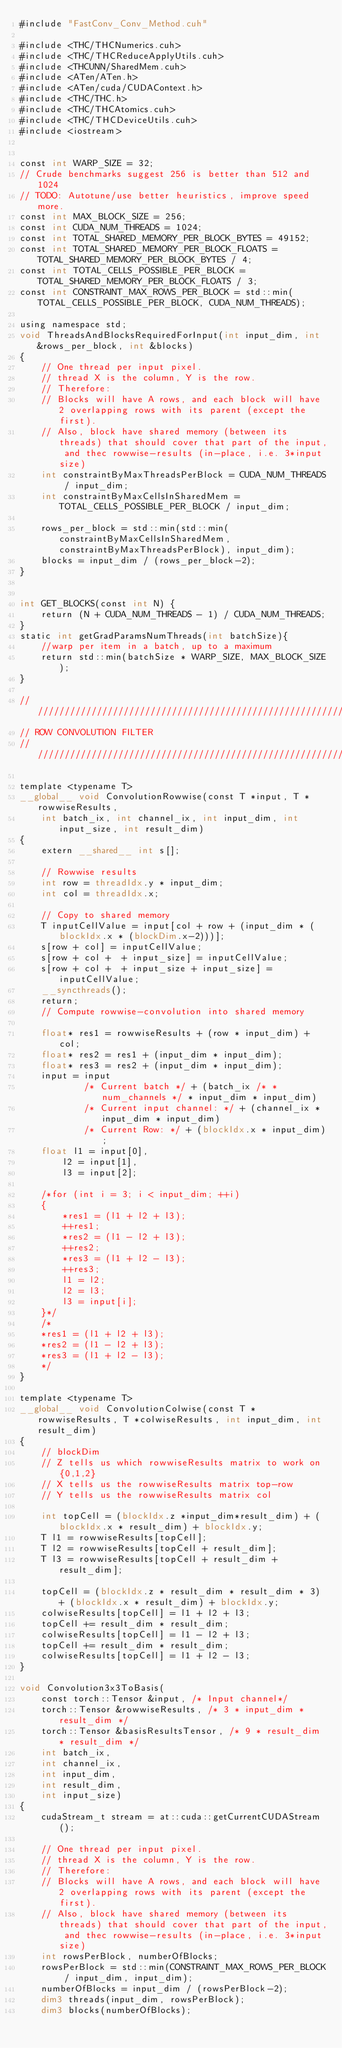<code> <loc_0><loc_0><loc_500><loc_500><_Cuda_>#include "FastConv_Conv_Method.cuh"

#include <THC/THCNumerics.cuh>
#include <THC/THCReduceApplyUtils.cuh>
#include <THCUNN/SharedMem.cuh>
#include <ATen/ATen.h>
#include <ATen/cuda/CUDAContext.h>
#include <THC/THC.h>
#include <THC/THCAtomics.cuh>
#include <THC/THCDeviceUtils.cuh>
#include <iostream>


const int WARP_SIZE = 32;
// Crude benchmarks suggest 256 is better than 512 and 1024
// TODO: Autotune/use better heuristics, improve speed more.
const int MAX_BLOCK_SIZE = 256;
const int CUDA_NUM_THREADS = 1024;
const int TOTAL_SHARED_MEMORY_PER_BLOCK_BYTES = 49152;
const int TOTAL_SHARED_MEMORY_PER_BLOCK_FLOATS = TOTAL_SHARED_MEMORY_PER_BLOCK_BYTES / 4;
const int TOTAL_CELLS_POSSIBLE_PER_BLOCK = TOTAL_SHARED_MEMORY_PER_BLOCK_FLOATS / 3;
const int CONSTRAINT_MAX_ROWS_PER_BLOCK = std::min(TOTAL_CELLS_POSSIBLE_PER_BLOCK, CUDA_NUM_THREADS);

using namespace std;
void ThreadsAndBlocksRequiredForInput(int input_dim, int &rows_per_block, int &blocks)
{
    // One thread per input pixel.
    // thread X is the column, Y is the row. 
    // Therefore:
    // Blocks will have A rows, and each block will have 2 overlapping rows with its parent (except the first).
    // Also, block have shared memory (between its threads) that should cover that part of the input, and thec rowwise-results (in-place, i.e. 3*input size)
    int constraintByMaxThreadsPerBlock = CUDA_NUM_THREADS / input_dim;
    int constraintByMaxCellsInSharedMem = TOTAL_CELLS_POSSIBLE_PER_BLOCK / input_dim;

    rows_per_block = std::min(std::min(constraintByMaxCellsInSharedMem, constraintByMaxThreadsPerBlock), input_dim);
    blocks = input_dim / (rows_per_block-2);
}


int GET_BLOCKS(const int N) {
    return (N + CUDA_NUM_THREADS - 1) / CUDA_NUM_THREADS;
}
static int getGradParamsNumThreads(int batchSize){
    //warp per item in a batch, up to a maximum
    return std::min(batchSize * WARP_SIZE, MAX_BLOCK_SIZE);    
}

///////////////////////////////////////////////////////////////////////
// ROW CONVOLUTION FILTER
///////////////////////////////////////////////////////////////////////

template <typename T>
__global__ void ConvolutionRowwise(const T *input, T *rowwiseResults, 
    int batch_ix, int channel_ix, int input_dim, int input_size, int result_dim)
{
    extern __shared__ int s[];

    // Rowwise results
    int row = threadIdx.y * input_dim;
    int col = threadIdx.x;
    
    // Copy to shared memory
    T inputCellValue = input[col + row + (input_dim * (blockIdx.x * (blockDim.x-2)))];
    s[row + col] = inputCellValue;
    s[row + col +  + input_size] = inputCellValue;
    s[row + col +  + input_size + input_size] = inputCellValue;
    __syncthreads();
    return;
    // Compute rowwise-convolution into shared memory
    
    float* res1 = rowwiseResults + (row * input_dim) + col;
    float* res2 = res1 + (input_dim * input_dim);
    float* res3 = res2 + (input_dim * input_dim);
    input = input 
            /* Current batch */ + (batch_ix /* * num_channels */ * input_dim * input_dim) 
            /* Current input channel: */ + (channel_ix * input_dim * input_dim)
            /* Current Row: */ + (blockIdx.x * input_dim);
    float l1 = input[0],
        l2 = input[1],
        l3 = input[2];
    
    /*for (int i = 3; i < input_dim; ++i)
    {
        *res1 = (l1 + l2 + l3);
        ++res1;
        *res2 = (l1 - l2 + l3);
        ++res2;
        *res3 = (l1 + l2 - l3);
        ++res3;
        l1 = l2;
        l2 = l3;
        l3 = input[i];
    }*/
    /*
    *res1 = (l1 + l2 + l3);
    *res2 = (l1 - l2 + l3);
    *res3 = (l1 + l2 - l3);
    */
}

template <typename T>
__global__ void ConvolutionColwise(const T *rowwiseResults, T *colwiseResults, int input_dim, int result_dim)
{
    // blockDim
    // Z tells us which rowwiseResults matrix to work on {0,1,2}
    // X tells us the rowwiseResults matrix top-row
    // Y tells us the rowwiseResults matrix col

    int topCell = (blockIdx.z *input_dim*result_dim) + (blockIdx.x * result_dim) + blockIdx.y;
    T l1 = rowwiseResults[topCell];
    T l2 = rowwiseResults[topCell + result_dim];
    T l3 = rowwiseResults[topCell + result_dim + result_dim];
    
    topCell = (blockIdx.z * result_dim * result_dim * 3) + (blockIdx.x * result_dim) + blockIdx.y;
    colwiseResults[topCell] = l1 + l2 + l3;
    topCell += result_dim * result_dim;
    colwiseResults[topCell] = l1 - l2 + l3;
    topCell += result_dim * result_dim;
    colwiseResults[topCell] = l1 + l2 - l3;
}

void Convolution3x3ToBasis(
    const torch::Tensor &input, /* Input channel*/
    torch::Tensor &rowwiseResults, /* 3 * input_dim * result_dim */
    torch::Tensor &basisResultsTensor, /* 9 * result_dim * result_dim */
    int batch_ix,
    int channel_ix,
    int input_dim,
    int result_dim,
    int input_size)
{
    cudaStream_t stream = at::cuda::getCurrentCUDAStream();

    // One thread per input pixel.
    // thread X is the column, Y is the row. 
    // Therefore:
    // Blocks will have A rows, and each block will have 2 overlapping rows with its parent (except the first).
    // Also, block have shared memory (between its threads) that should cover that part of the input, and thec rowwise-results (in-place, i.e. 3*input size)
    int rowsPerBlock, numberOfBlocks;
    rowsPerBlock = std::min(CONSTRAINT_MAX_ROWS_PER_BLOCK / input_dim, input_dim);
    numberOfBlocks = input_dim / (rowsPerBlock-2);
    dim3 threads(input_dim, rowsPerBlock);
    dim3 blocks(numberOfBlocks);</code> 